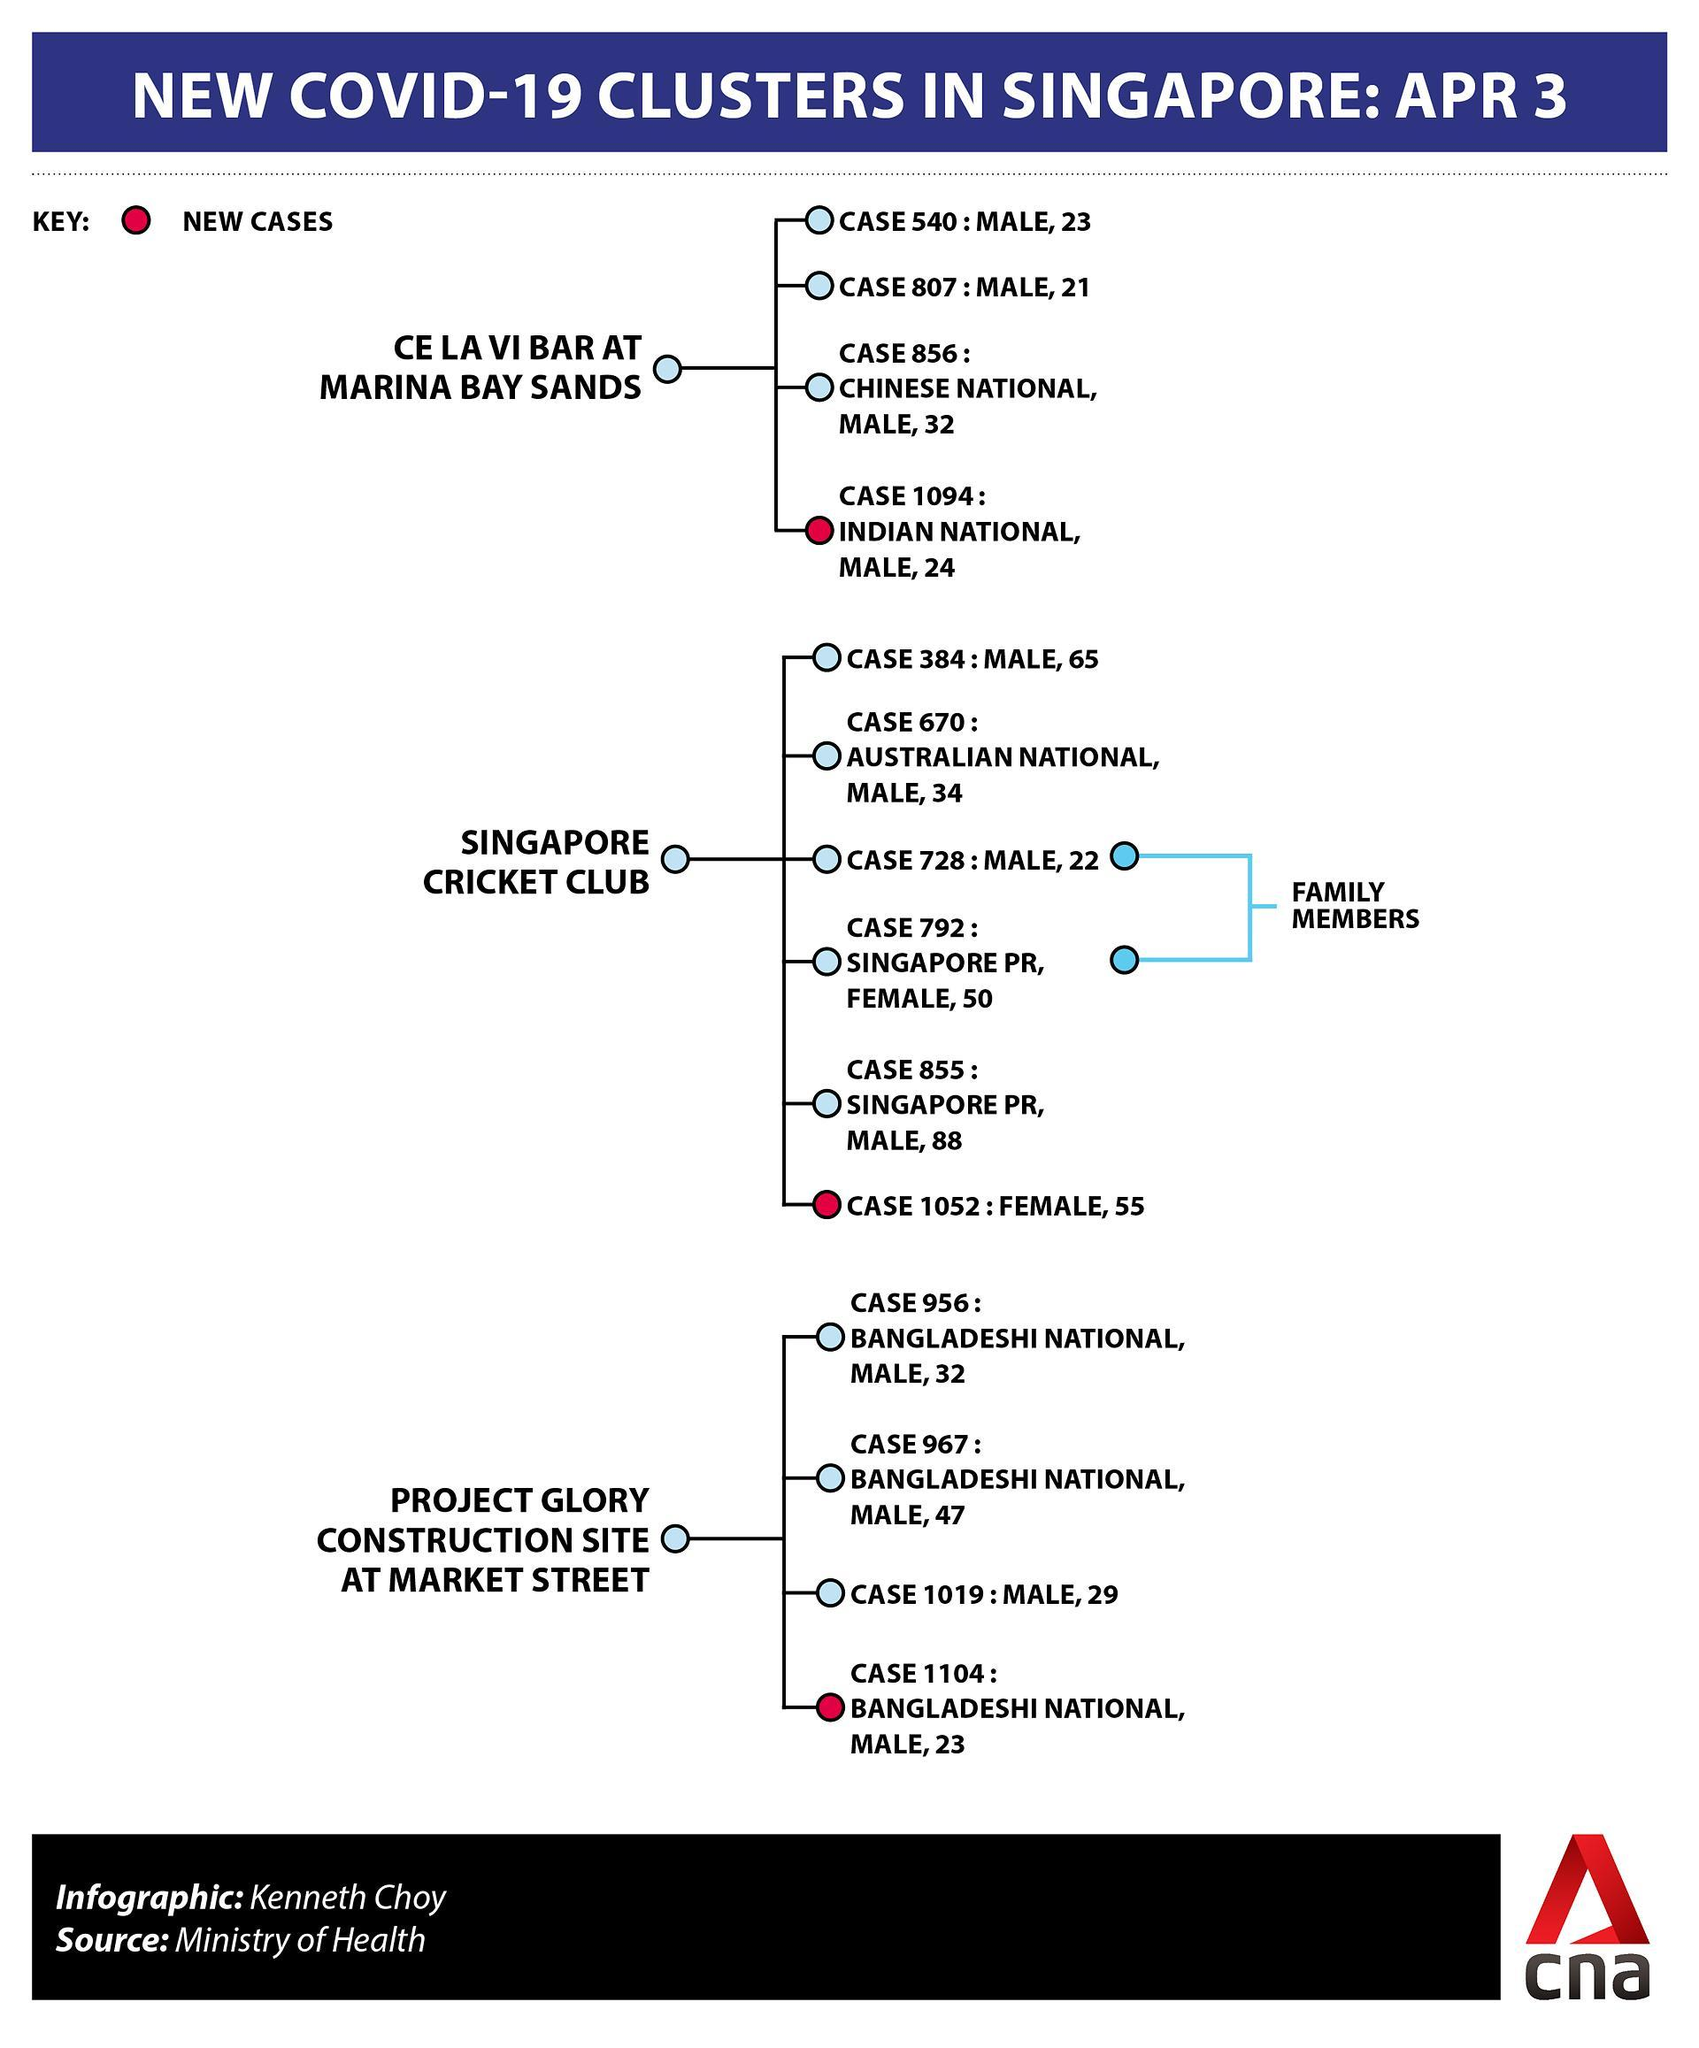What is the nationality of the new patient of market street?
Answer the question with a short phrase. Bangladeshi What is the gender of the new patient of market street? male How many cases are there in the market street cluster? 4 How many female patients are there in market street cluster? 0 What is the nationality of the new patient of marina bay bands? Indian national What is the gender of the new patient of Singapore cricket club? female What is the case number of the new patient of market street? case 1104 What is the age of the new patient of marina bay bands? 24 what are the case numbers of the patients who are family members? case 728, case 792 What is the case number of the new patient of marina bay bands? 1094 What is the case number of the new patient of Singapore cricket club? 1052 What is the age of the new patient of Singapore cricket club? 55 How many female patients are there in cricket club cluster? 2 How many cases are there in the cricket club cluster? 6 How many cases are there in the marina bay bands cluster? 4 How many male patients are there in marina bay bands cluster? 4 What is the gender of the new patient of marina bay bands? male 